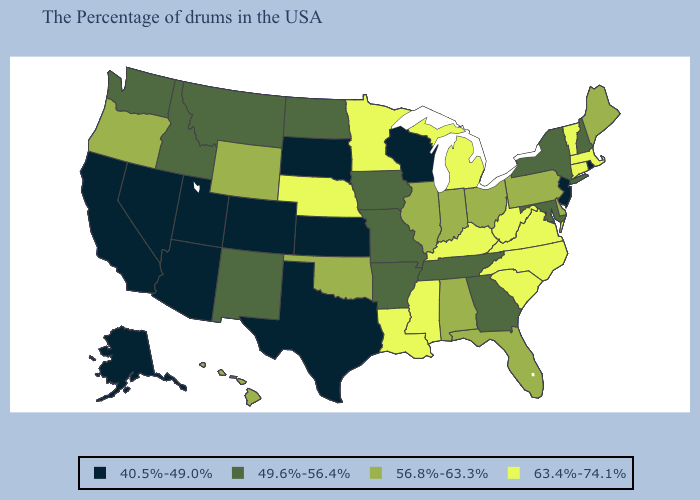What is the highest value in the USA?
Short answer required. 63.4%-74.1%. Does Wisconsin have a higher value than South Dakota?
Short answer required. No. Name the states that have a value in the range 63.4%-74.1%?
Answer briefly. Massachusetts, Vermont, Connecticut, Virginia, North Carolina, South Carolina, West Virginia, Michigan, Kentucky, Mississippi, Louisiana, Minnesota, Nebraska. What is the value of Utah?
Keep it brief. 40.5%-49.0%. Does Kentucky have the highest value in the USA?
Be succinct. Yes. Among the states that border Iowa , which have the highest value?
Give a very brief answer. Minnesota, Nebraska. Does North Dakota have the lowest value in the MidWest?
Answer briefly. No. Name the states that have a value in the range 49.6%-56.4%?
Give a very brief answer. New Hampshire, New York, Maryland, Georgia, Tennessee, Missouri, Arkansas, Iowa, North Dakota, New Mexico, Montana, Idaho, Washington. What is the highest value in the South ?
Keep it brief. 63.4%-74.1%. Does the map have missing data?
Concise answer only. No. Does Colorado have a lower value than Texas?
Give a very brief answer. No. What is the value of Illinois?
Keep it brief. 56.8%-63.3%. What is the value of Wisconsin?
Quick response, please. 40.5%-49.0%. How many symbols are there in the legend?
Quick response, please. 4. What is the value of Idaho?
Concise answer only. 49.6%-56.4%. 